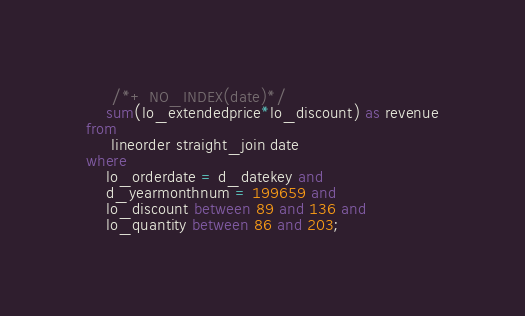Convert code to text. <code><loc_0><loc_0><loc_500><loc_500><_SQL_>	 /*+ NO_INDEX(date)*/
    sum(lo_extendedprice*lo_discount) as revenue
from
	 lineorder straight_join date
where
    lo_orderdate = d_datekey and
    d_yearmonthnum = 199659 and
    lo_discount between 89 and 136 and
    lo_quantity between 86 and 203;
</code> 